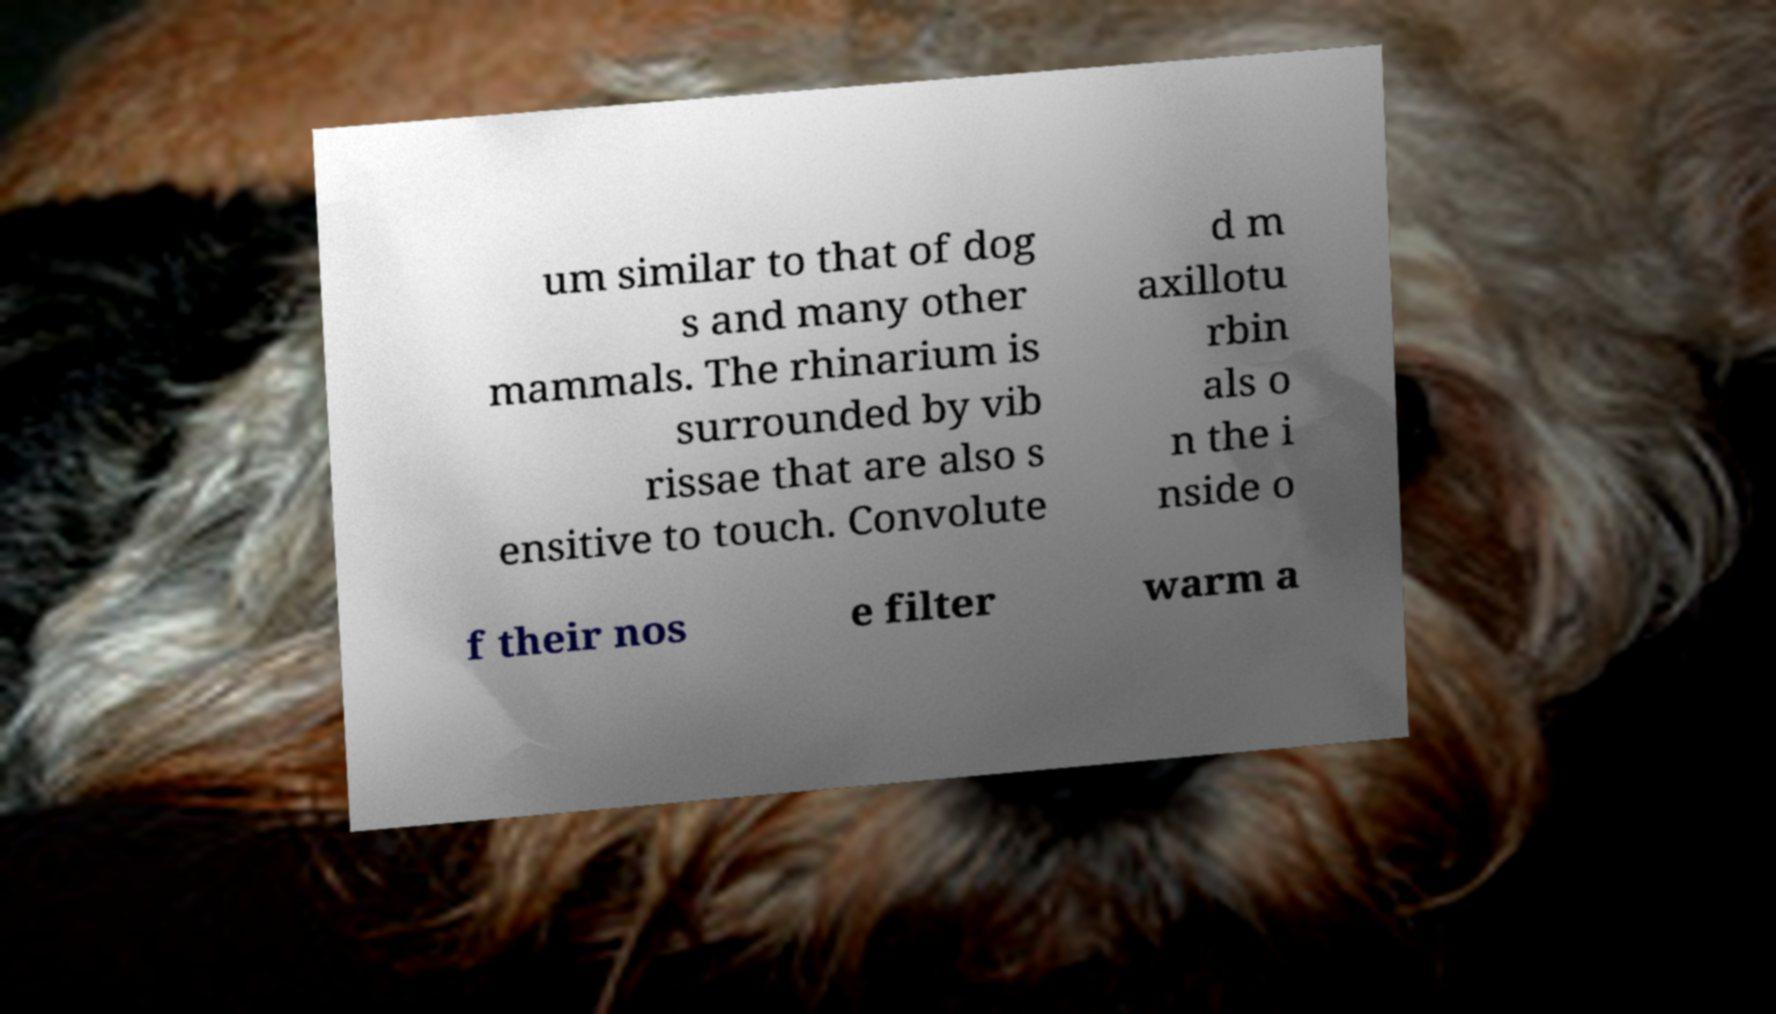Please read and relay the text visible in this image. What does it say? um similar to that of dog s and many other mammals. The rhinarium is surrounded by vib rissae that are also s ensitive to touch. Convolute d m axillotu rbin als o n the i nside o f their nos e filter warm a 